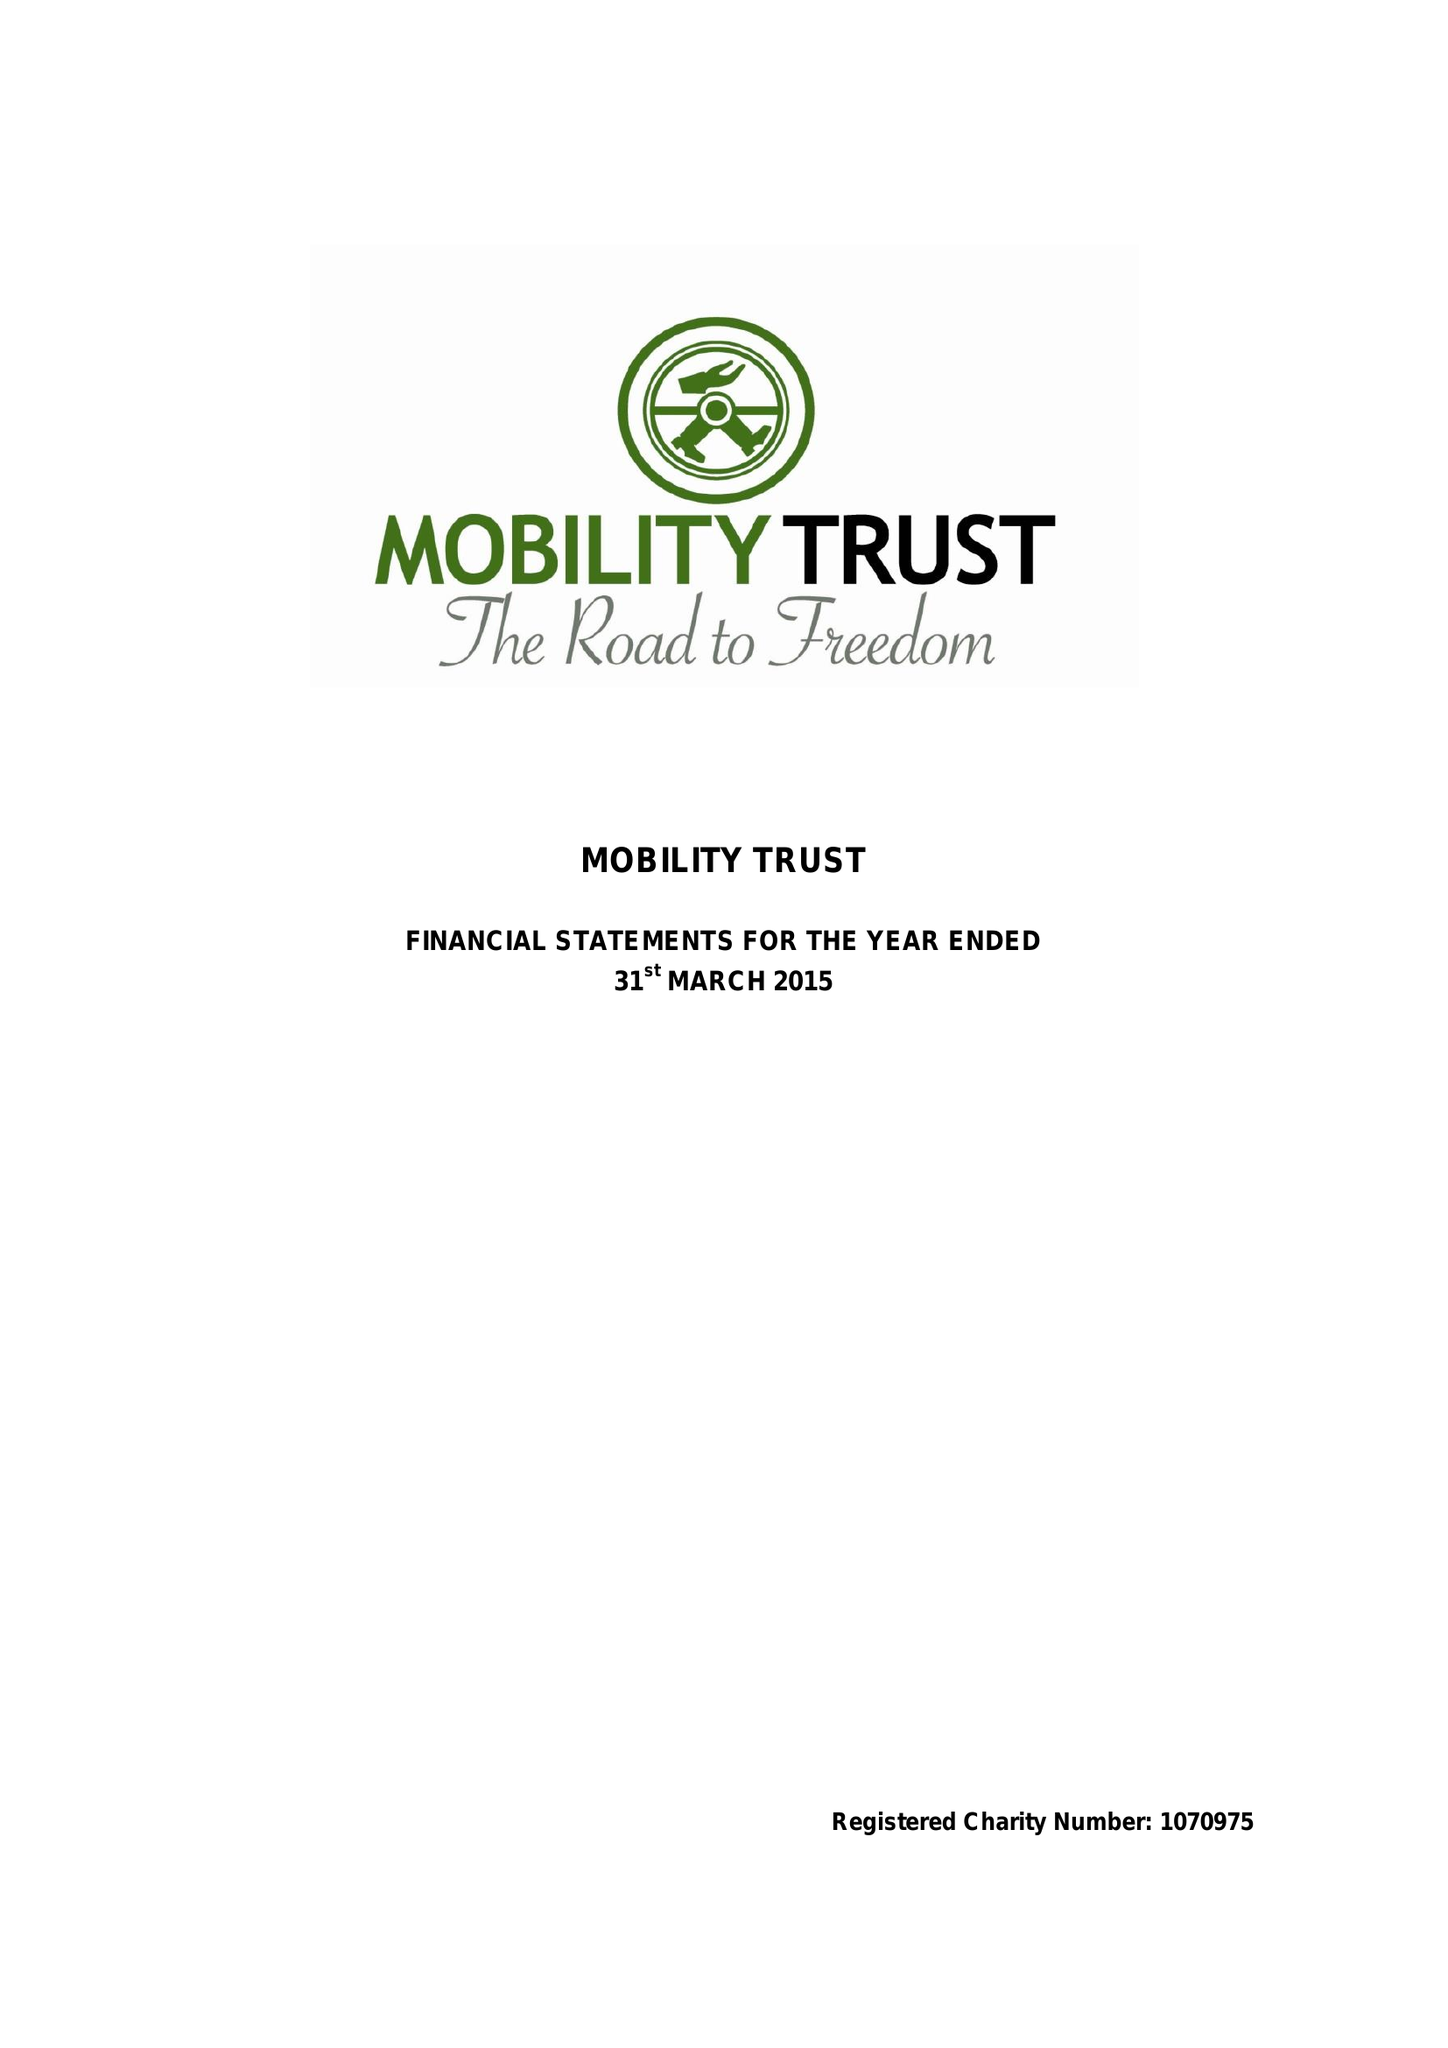What is the value for the income_annually_in_british_pounds?
Answer the question using a single word or phrase. 313958.00 